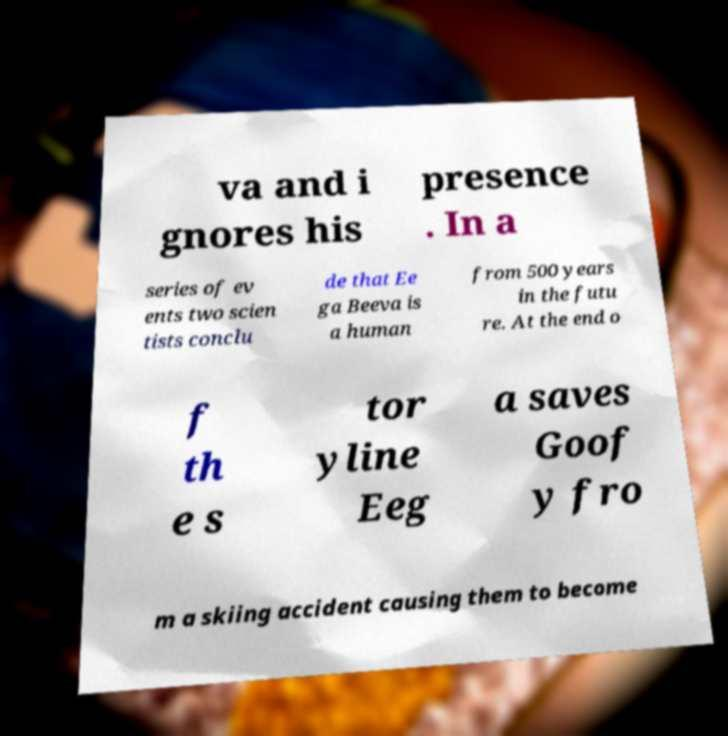Can you accurately transcribe the text from the provided image for me? va and i gnores his presence . In a series of ev ents two scien tists conclu de that Ee ga Beeva is a human from 500 years in the futu re. At the end o f th e s tor yline Eeg a saves Goof y fro m a skiing accident causing them to become 